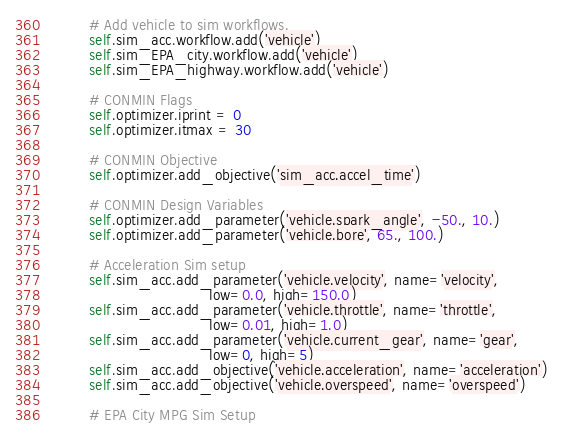Convert code to text. <code><loc_0><loc_0><loc_500><loc_500><_Python_>        # Add vehicle to sim workflows.
        self.sim_acc.workflow.add('vehicle')
        self.sim_EPA_city.workflow.add('vehicle')
        self.sim_EPA_highway.workflow.add('vehicle')
    
        # CONMIN Flags
        self.optimizer.iprint = 0
        self.optimizer.itmax = 30
        
        # CONMIN Objective 
        self.optimizer.add_objective('sim_acc.accel_time')
        
        # CONMIN Design Variables 
        self.optimizer.add_parameter('vehicle.spark_angle', -50., 10.)
        self.optimizer.add_parameter('vehicle.bore', 65., 100.)
        
        # Acceleration Sim setup
        self.sim_acc.add_parameter('vehicle.velocity', name='velocity',
                                  low=0.0, high=150.0)
        self.sim_acc.add_parameter('vehicle.throttle', name='throttle',
                                  low=0.01, high=1.0)
        self.sim_acc.add_parameter('vehicle.current_gear', name='gear',
                                  low=0, high=5)
        self.sim_acc.add_objective('vehicle.acceleration', name='acceleration')
        self.sim_acc.add_objective('vehicle.overspeed', name='overspeed')
        
        # EPA City MPG Sim Setup</code> 